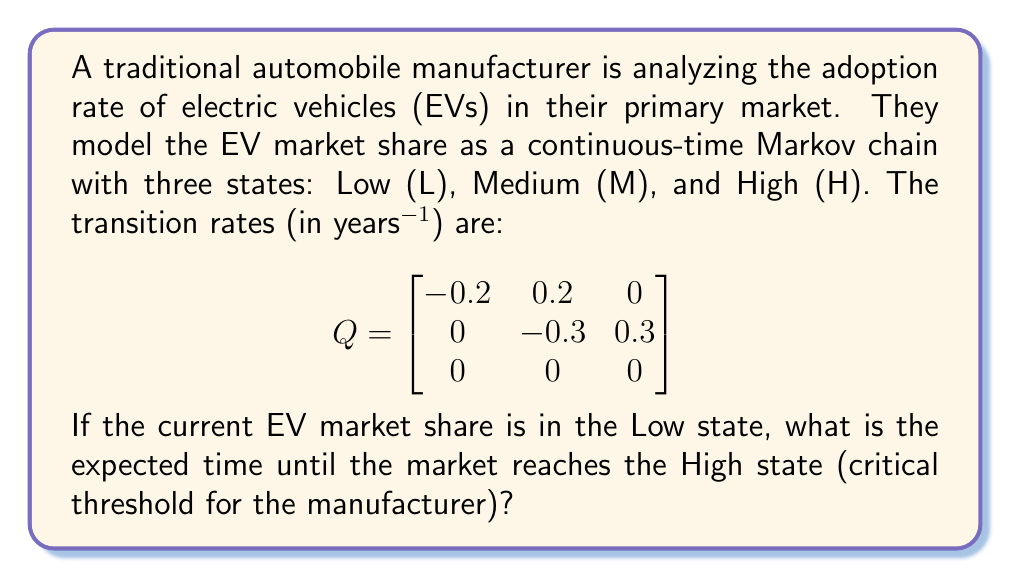Teach me how to tackle this problem. To solve this problem, we'll use the properties of continuous-time Markov chains and the concept of mean hitting times.

Step 1: Identify the absorbing state
The High (H) state is an absorbing state, as there are no transitions out of it.

Step 2: Set up the system of equations for mean hitting times
Let $m_L$ and $m_M$ be the mean hitting times to state H from states L and M, respectively. We can write:

$$ m_L = \frac{1}{0.2} + m_M $$
$$ m_M = \frac{1}{0.3} + 0 $$

The first equation states that from L, we wait an average time of $1/0.2$ years before transitioning to M, then take $m_M$ more years to reach H.
The second equation states that from M, we wait an average time of $1/0.3$ years before transitioning directly to H.

Step 3: Solve the system of equations
From the second equation:
$$ m_M = \frac{1}{0.3} = 3.33 \text{ years} $$

Substituting this into the first equation:
$$ m_L = \frac{1}{0.2} + 3.33 = 5 + 3.33 = 8.33 \text{ years} $$

Therefore, starting from the Low state, the expected time to reach the High state is 8.33 years.
Answer: 8.33 years 